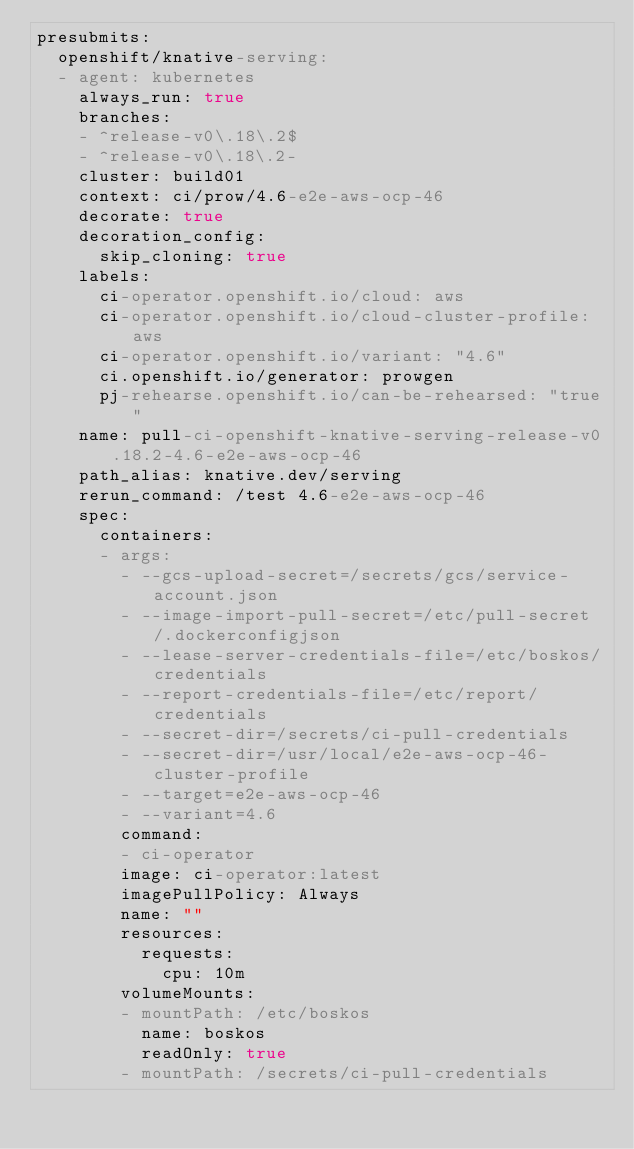<code> <loc_0><loc_0><loc_500><loc_500><_YAML_>presubmits:
  openshift/knative-serving:
  - agent: kubernetes
    always_run: true
    branches:
    - ^release-v0\.18\.2$
    - ^release-v0\.18\.2-
    cluster: build01
    context: ci/prow/4.6-e2e-aws-ocp-46
    decorate: true
    decoration_config:
      skip_cloning: true
    labels:
      ci-operator.openshift.io/cloud: aws
      ci-operator.openshift.io/cloud-cluster-profile: aws
      ci-operator.openshift.io/variant: "4.6"
      ci.openshift.io/generator: prowgen
      pj-rehearse.openshift.io/can-be-rehearsed: "true"
    name: pull-ci-openshift-knative-serving-release-v0.18.2-4.6-e2e-aws-ocp-46
    path_alias: knative.dev/serving
    rerun_command: /test 4.6-e2e-aws-ocp-46
    spec:
      containers:
      - args:
        - --gcs-upload-secret=/secrets/gcs/service-account.json
        - --image-import-pull-secret=/etc/pull-secret/.dockerconfigjson
        - --lease-server-credentials-file=/etc/boskos/credentials
        - --report-credentials-file=/etc/report/credentials
        - --secret-dir=/secrets/ci-pull-credentials
        - --secret-dir=/usr/local/e2e-aws-ocp-46-cluster-profile
        - --target=e2e-aws-ocp-46
        - --variant=4.6
        command:
        - ci-operator
        image: ci-operator:latest
        imagePullPolicy: Always
        name: ""
        resources:
          requests:
            cpu: 10m
        volumeMounts:
        - mountPath: /etc/boskos
          name: boskos
          readOnly: true
        - mountPath: /secrets/ci-pull-credentials</code> 